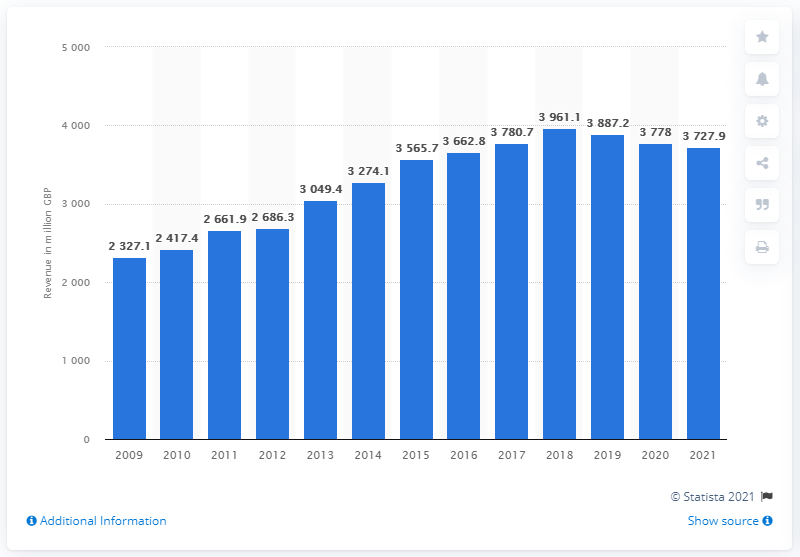Identify some key points in this picture. In 2021, John Lewis' annual sales revenue was 3727.9 million pounds. 